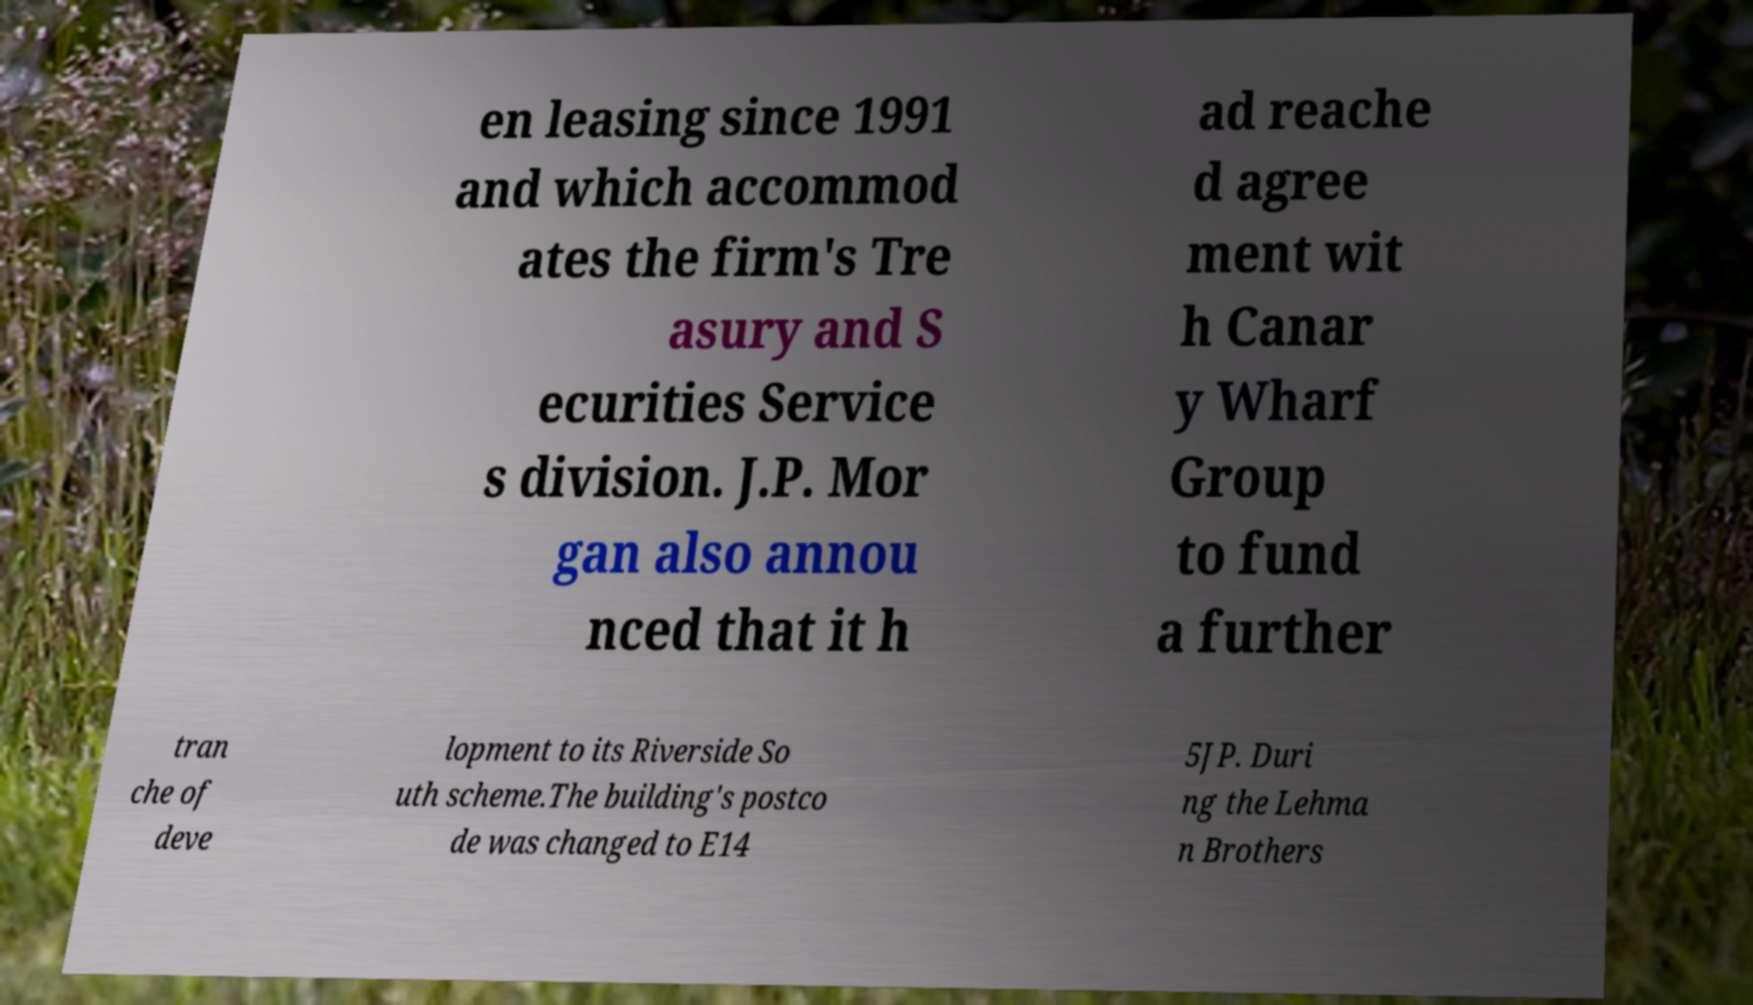Please identify and transcribe the text found in this image. en leasing since 1991 and which accommod ates the firm's Tre asury and S ecurities Service s division. J.P. Mor gan also annou nced that it h ad reache d agree ment wit h Canar y Wharf Group to fund a further tran che of deve lopment to its Riverside So uth scheme.The building's postco de was changed to E14 5JP. Duri ng the Lehma n Brothers 